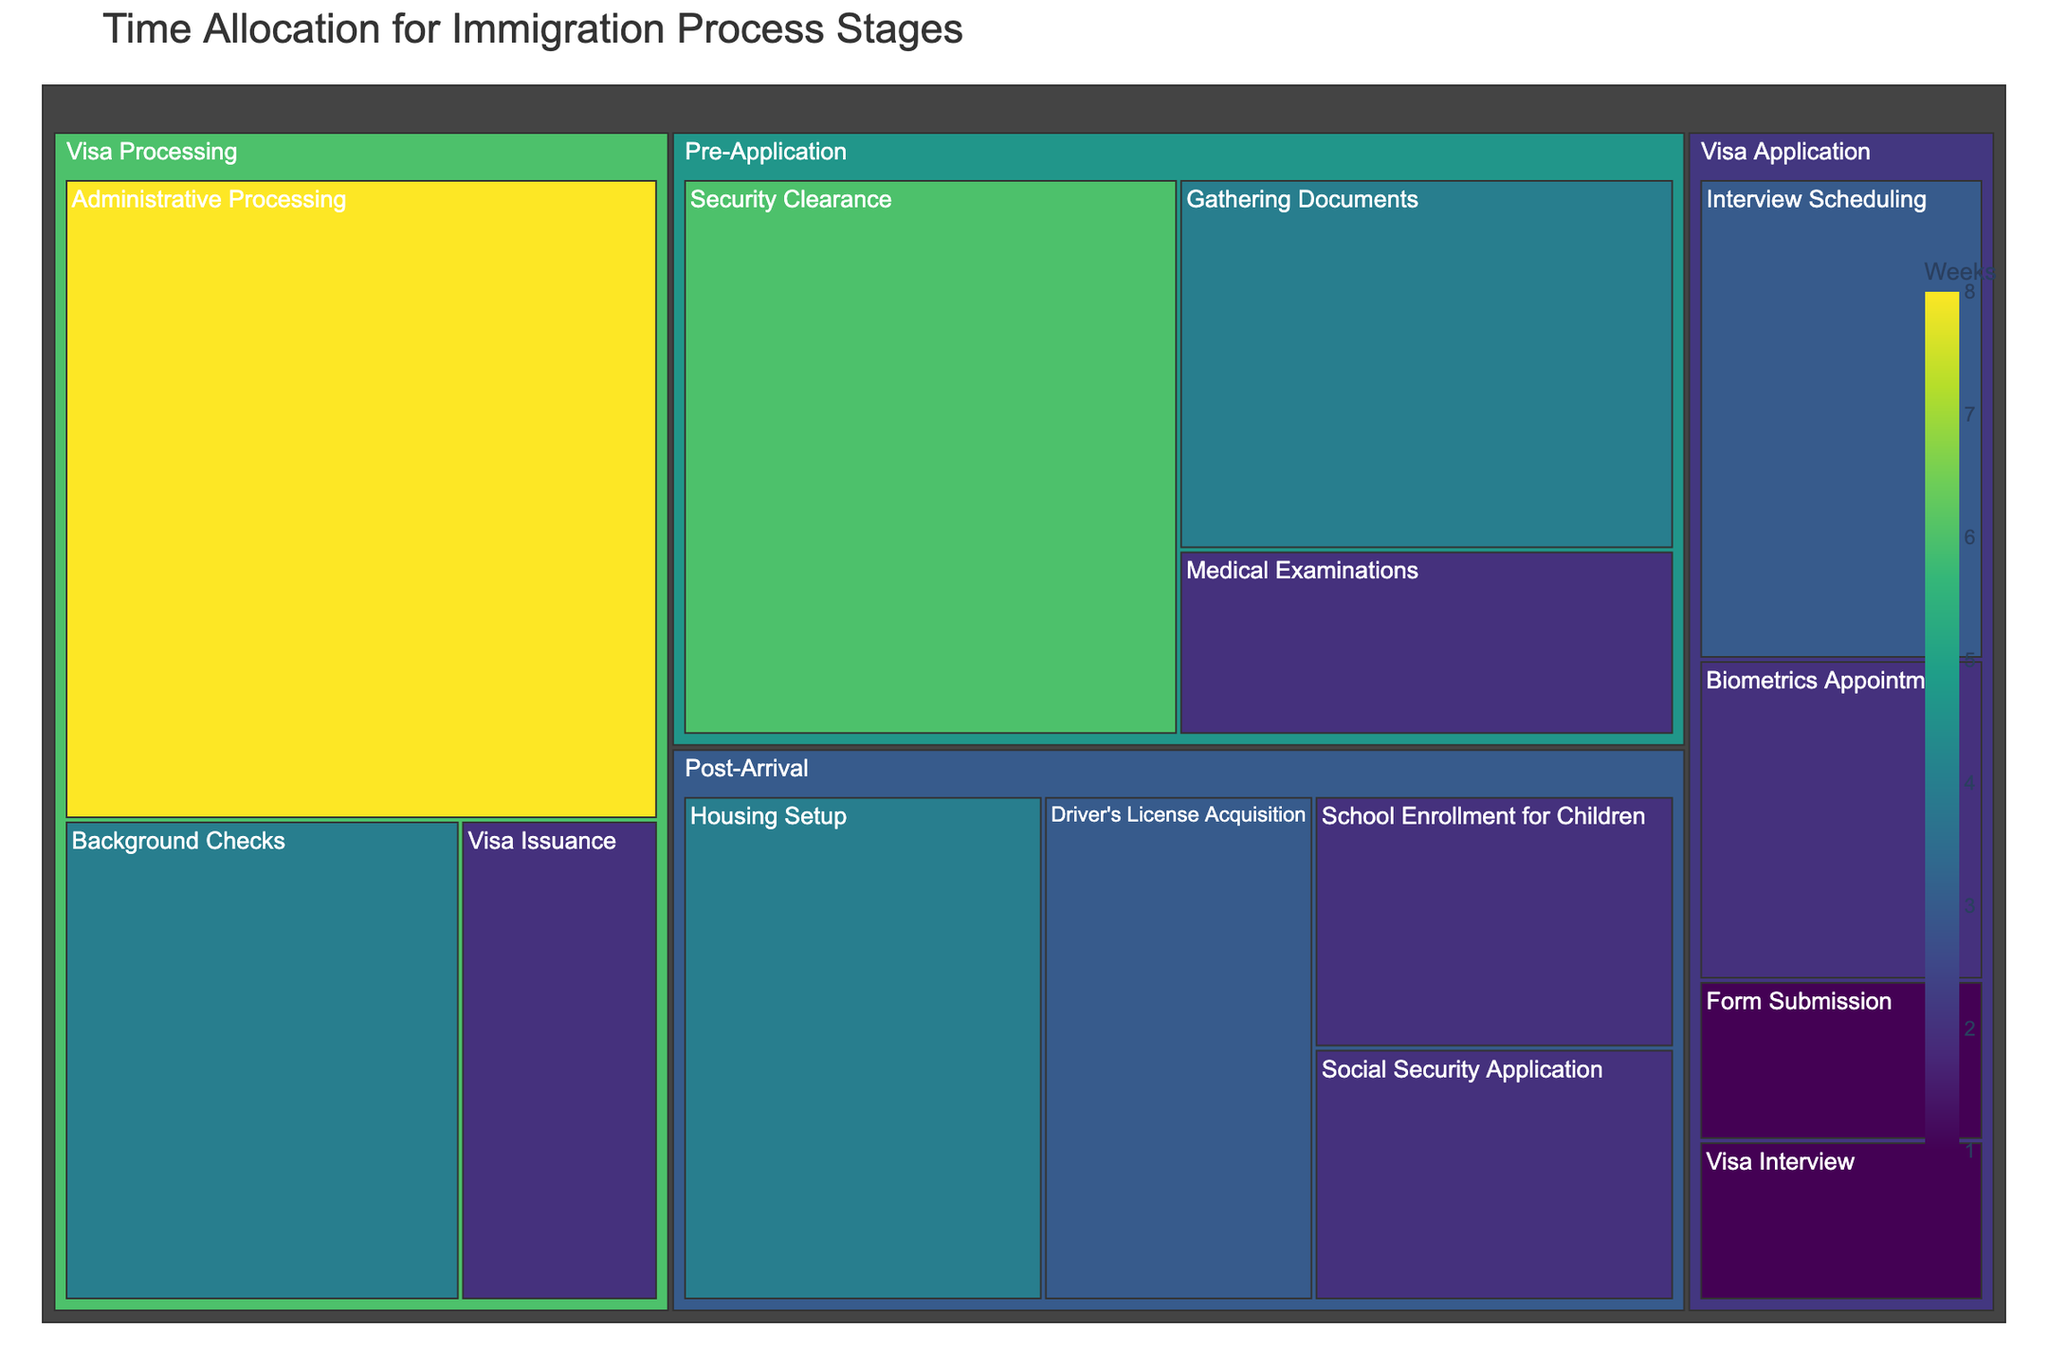What is the total time allocated for the Pre-Application stage? Sum the weeks for all subcategories in the Pre-Application stage: Gathering Documents (4), Medical Examinations (2), and Security Clearance (6). So, the total time is 4 + 2 + 6 = 12 weeks.
Answer: 12 weeks Which stage has the highest total time allocation? Compare the total times for each stage: Pre-Application (12 weeks), Visa Application (7 weeks), Visa Processing (14 weeks), Post-Arrival (11 weeks). Visa Processing has the highest total time allocation.
Answer: Visa Processing How many weeks are allocated to the Visa Issuance subcategory? Refer to the Visa Processing category, which includes Visa Issuance. The specific allocation is 2 weeks.
Answer: 2 weeks What is the shortest subcategory in terms of time allocation? Review all subcategories and their corresponding times. The shortest are Form Submission and Visa Interview, both at 1 week.
Answer: Form Submission/Visa Interview What is the time difference between the Security Clearance and the Medical Examinations subcategories? Subtract the time for Medical Examinations (2 weeks) from Security Clearance (6 weeks). So, 6 - 2 = 4 weeks.
Answer: 4 weeks How does the time for Background Checks compare to the time for Housing Setup? Background Checks (4 weeks) and Housing Setup (4 weeks) have equal time allocations.
Answer: Equal What's the average time allocated across all subcategories? Sum all weeks and divide by the number of subcategories. Total weeks = 44, number of subcategories = 14; thus the average is 44 / 14 ≈ 3.14 weeks.
Answer: 3.14 weeks Which stage requires the longest single subcategory allocation and what is it? Identify the longest subcategory in each stage: Pre-Application (Security Clearance - 6 weeks), Visa Application (Interview Scheduling - 3 weeks), Visa Processing (Administrative Processing - 8 weeks), Post-Arrival (Housing Setup - 4 weeks). The longest single subcategory is Administrative Processing in Visa Processing with 8 weeks.
Answer: Visa Processing: Administrative Processing (8 weeks) What subcategories fall under the Visa Application stage and their total time? Identify subcategories: Form Submission (1 week), Biometrics Appointment (2 weeks), Interview Scheduling (3 weeks), Visa Interview (1 week). Total time is 1 + 2 + 3 + 1 = 7 weeks.
Answer: Form Submission, Biometrics Appointment, Interview Scheduling, Visa Interview; 7 weeks What is the ratio of the total time for Visa Processing to Post-Arrival stages? Visa Processing total = 14 weeks, Post-Arrival total = 11 weeks. The ratio is 14:11.
Answer: 14:11 